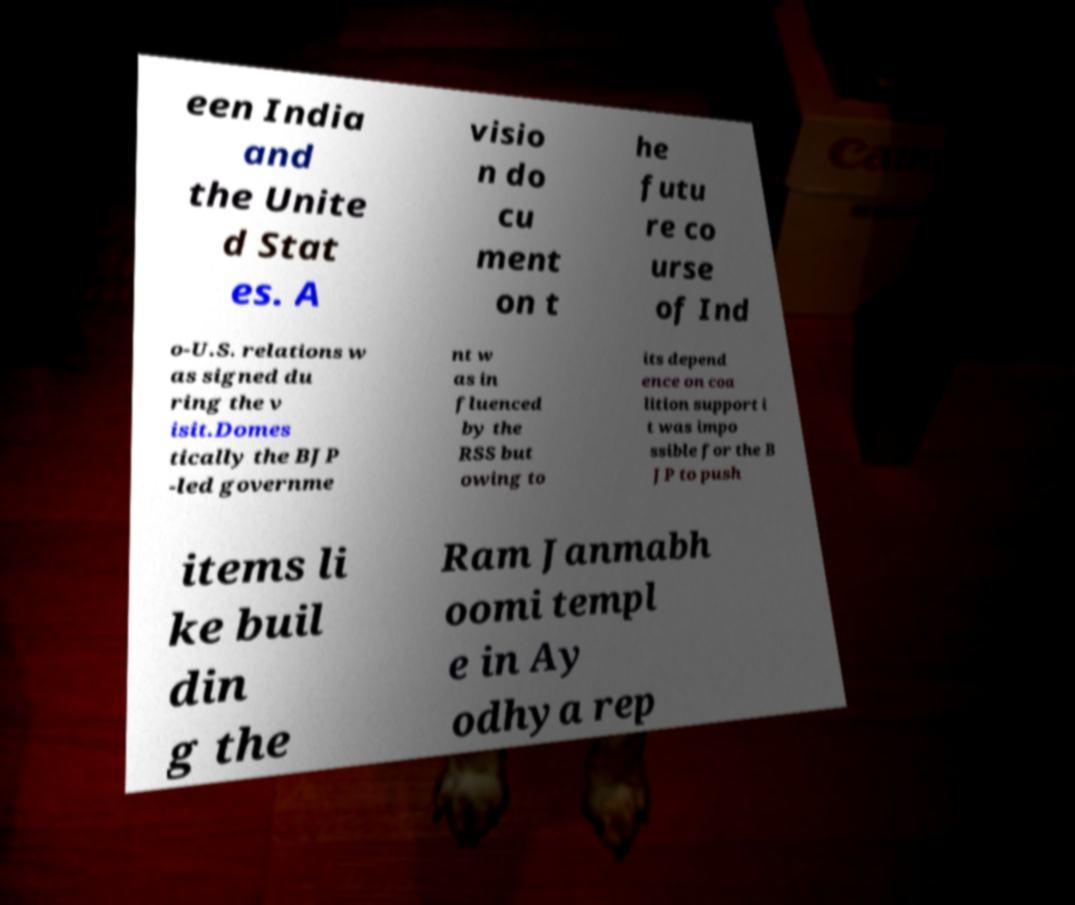Can you accurately transcribe the text from the provided image for me? een India and the Unite d Stat es. A visio n do cu ment on t he futu re co urse of Ind o-U.S. relations w as signed du ring the v isit.Domes tically the BJP -led governme nt w as in fluenced by the RSS but owing to its depend ence on coa lition support i t was impo ssible for the B JP to push items li ke buil din g the Ram Janmabh oomi templ e in Ay odhya rep 